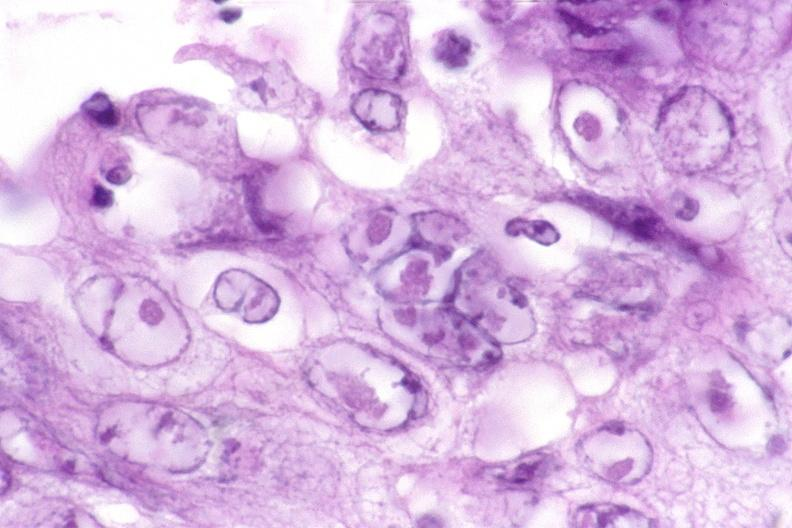where is this from?
Answer the question using a single word or phrase. Gastrointestinal system 